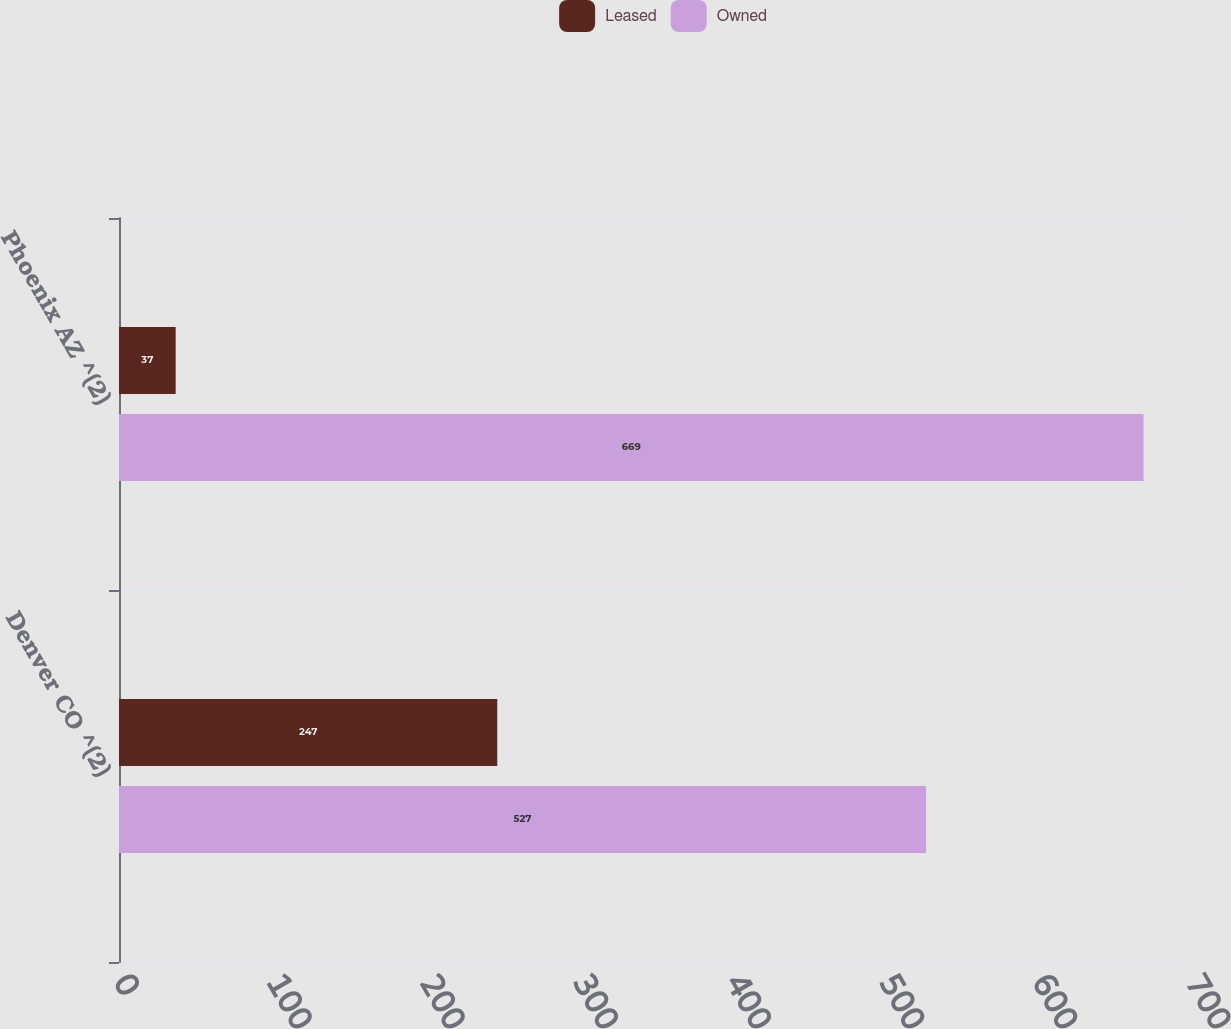Convert chart. <chart><loc_0><loc_0><loc_500><loc_500><stacked_bar_chart><ecel><fcel>Denver CO ^(2)<fcel>Phoenix AZ ^(2)<nl><fcel>Leased<fcel>247<fcel>37<nl><fcel>Owned<fcel>527<fcel>669<nl></chart> 